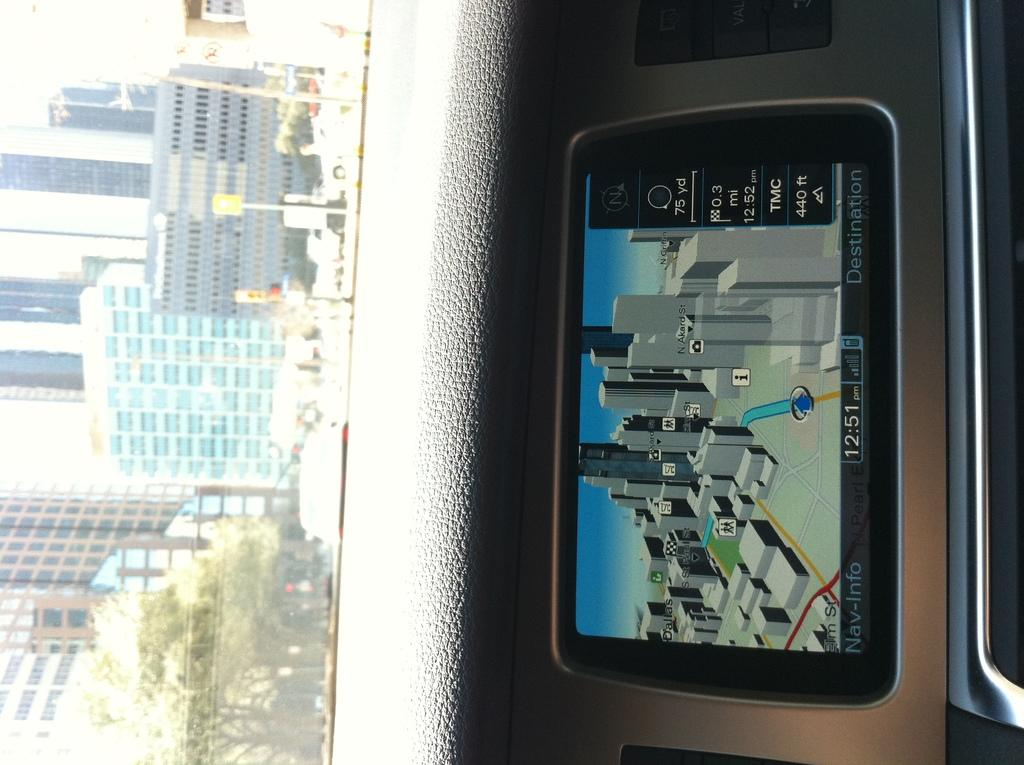<image>
Provide a brief description of the given image. A navigation image of a city on a Nav-Info device on a dashboard with a city scape outside the window. 